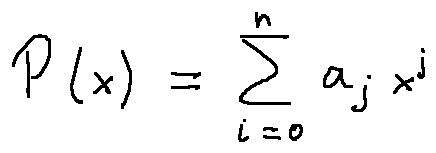Convert formula to latex. <formula><loc_0><loc_0><loc_500><loc_500>P ( x ) = \sum \lim i t s _ { i = 0 } ^ { n } a _ { j } x ^ { j }</formula> 